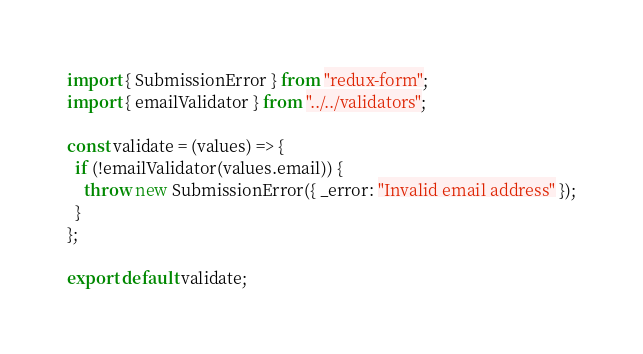<code> <loc_0><loc_0><loc_500><loc_500><_JavaScript_>import { SubmissionError } from "redux-form";
import { emailValidator } from "../../validators";

const validate = (values) => {
  if (!emailValidator(values.email)) {
    throw new SubmissionError({ _error: "Invalid email address" });
  }
};

export default validate;
</code> 